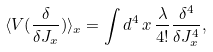<formula> <loc_0><loc_0><loc_500><loc_500>\langle V ( \frac { \delta } { \delta J _ { x } } ) \rangle _ { x } = \int d ^ { 4 } \, x \, \frac { \lambda } { 4 ! } \frac { \delta ^ { 4 } } { \delta J _ { x } ^ { 4 } } ,</formula> 